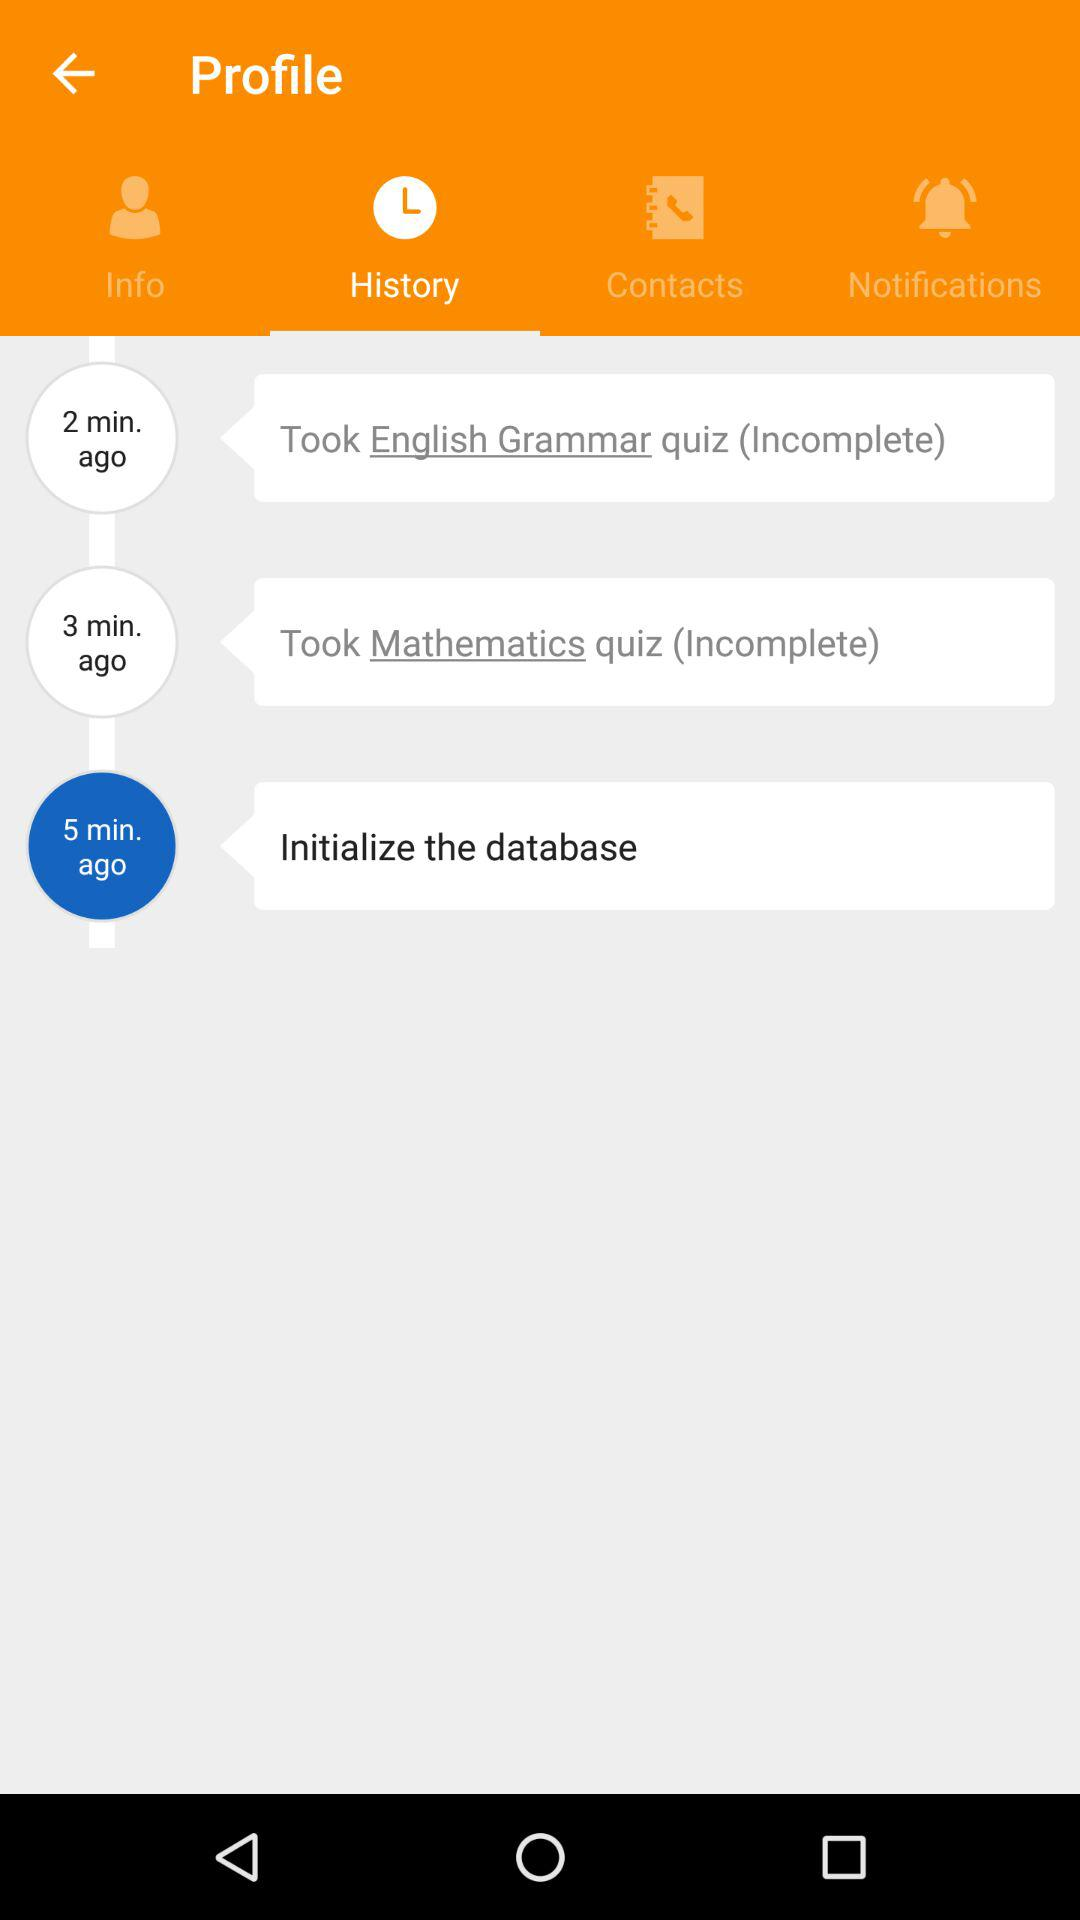How many incomplete quizzes do I have?
Answer the question using a single word or phrase. 2 